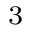<formula> <loc_0><loc_0><loc_500><loc_500>_ { 3 }</formula> 